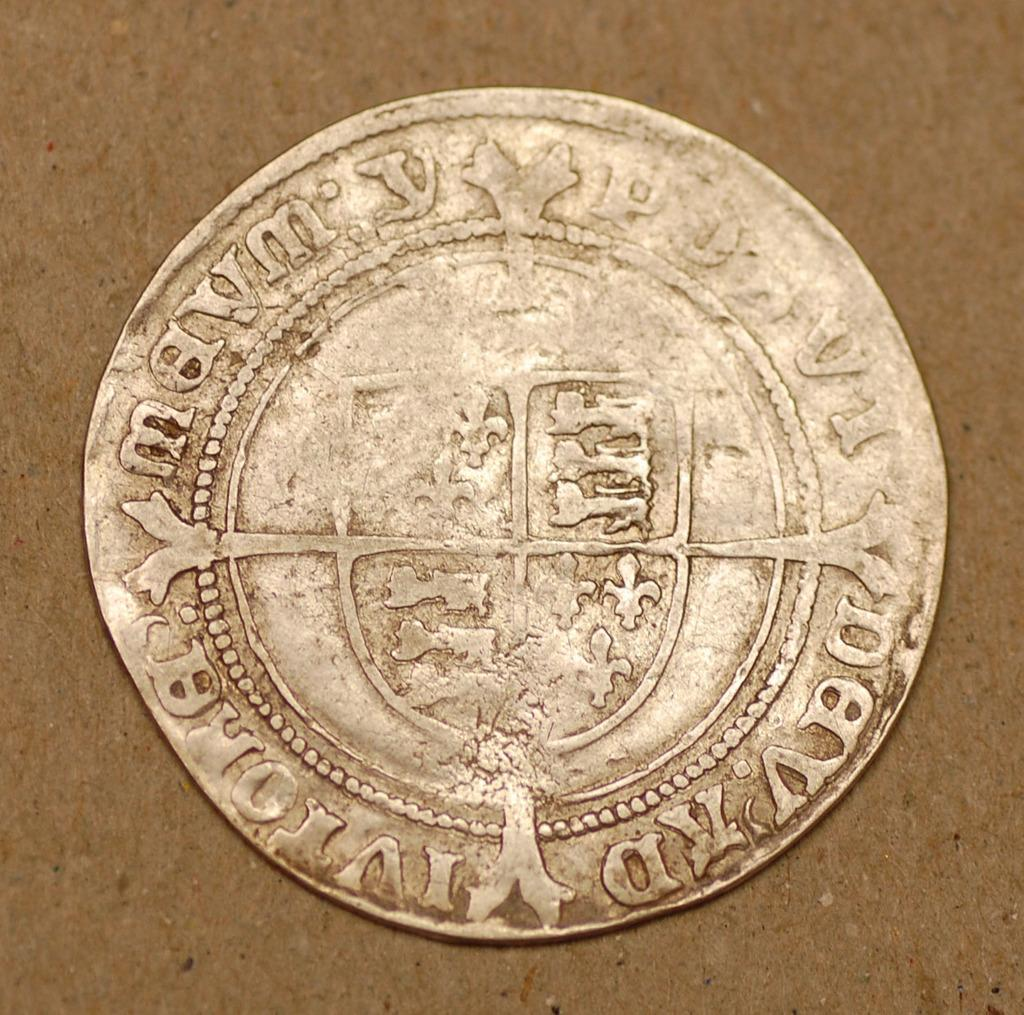What is the main object in the foreground of the image? There is a coin in the foreground of the image. What features can be seen on the coin? The coin has a logo and text printed on it. On what surface is the coin placed? The coin is placed on a surface. What subject is the teacher teaching during recess in the image? There is no teacher or recess present in the image; it only features a coin with a logo and text on a surface. 